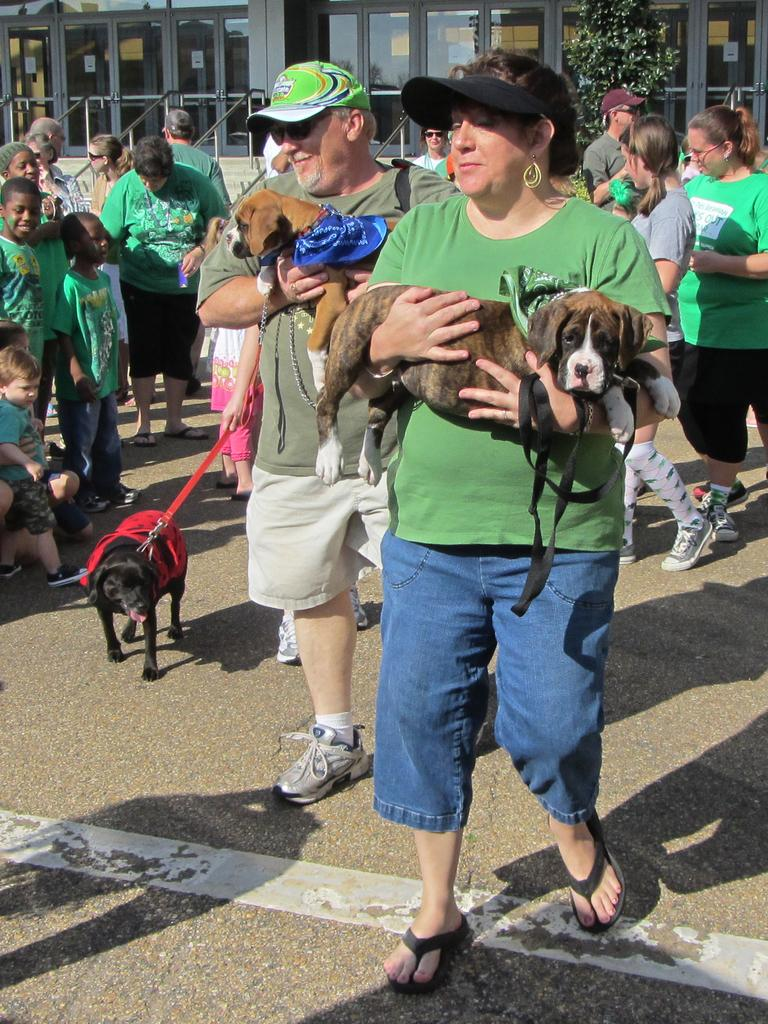Who is the main subject in the image? There is a woman in the image. What is the woman doing in the image? The woman is walking in the image. What is the woman holding in the image? The woman is holding a dog in the image. How many people are present in the image? There are many people in the image. What are the people doing in the image? The people are holding dogs in the image. How does the woman order her dog to sit in the image? There is no indication in the image that the woman is ordering her dog to sit. 